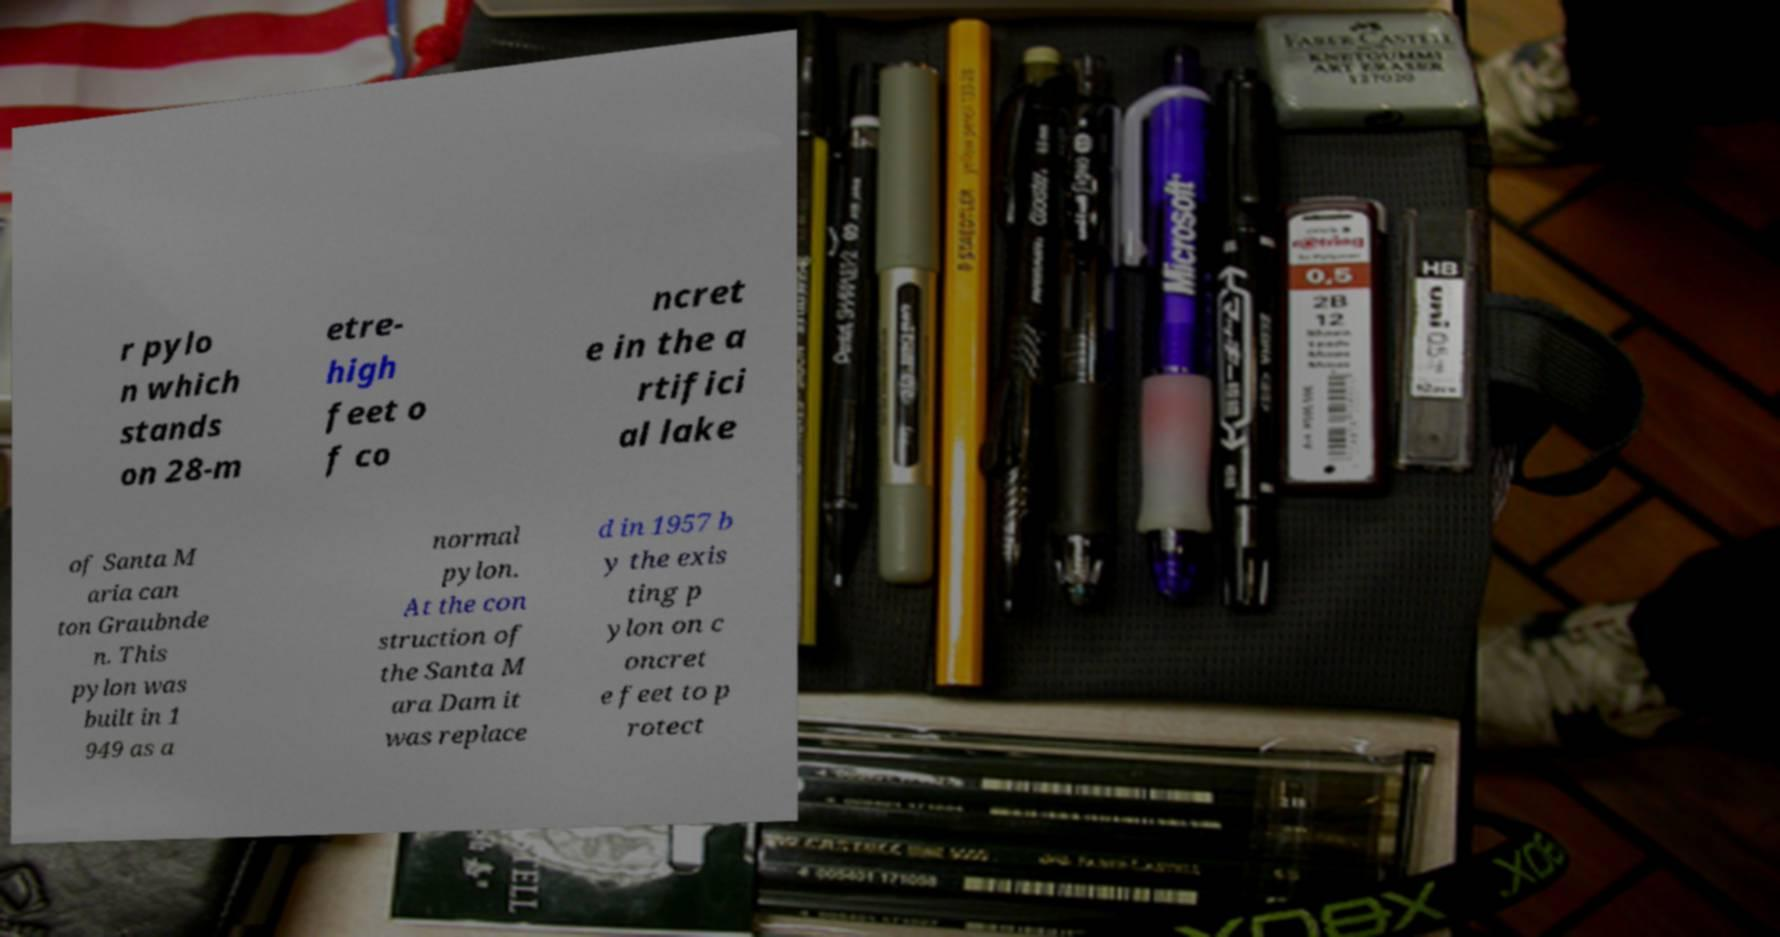Could you extract and type out the text from this image? r pylo n which stands on 28-m etre- high feet o f co ncret e in the a rtifici al lake of Santa M aria can ton Graubnde n. This pylon was built in 1 949 as a normal pylon. At the con struction of the Santa M ara Dam it was replace d in 1957 b y the exis ting p ylon on c oncret e feet to p rotect 